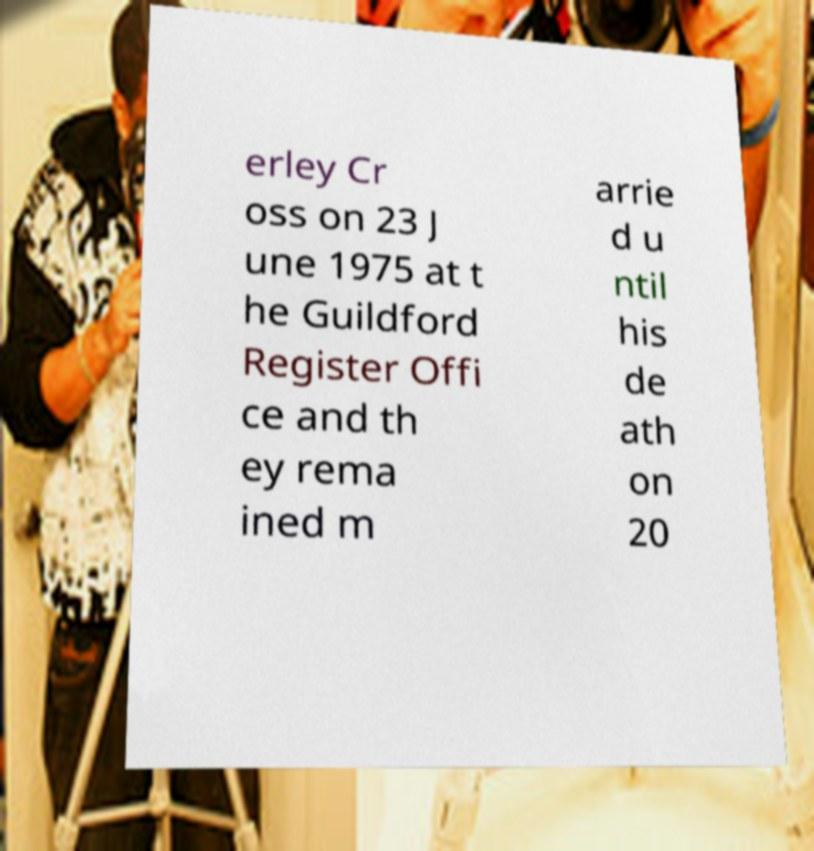For documentation purposes, I need the text within this image transcribed. Could you provide that? erley Cr oss on 23 J une 1975 at t he Guildford Register Offi ce and th ey rema ined m arrie d u ntil his de ath on 20 